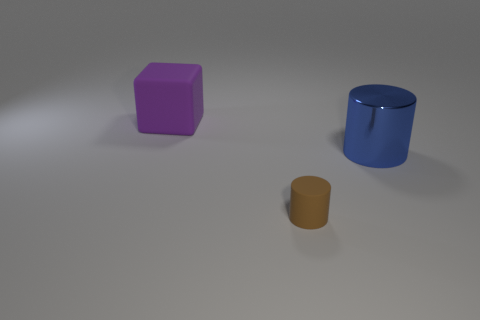There is a matte thing that is to the right of the big thing that is behind the big thing that is right of the purple object; what is its size?
Offer a very short reply. Small. Is the color of the large matte cube the same as the large metallic cylinder?
Offer a very short reply. No. Is there any other thing that is the same size as the cube?
Provide a succinct answer. Yes. How many brown matte cylinders are in front of the block?
Give a very brief answer. 1. Are there an equal number of tiny matte cylinders on the right side of the blue metal object and gray balls?
Your answer should be compact. Yes. What number of things are either cubes or tiny purple blocks?
Your response must be concise. 1. Is there anything else that has the same shape as the large purple thing?
Your answer should be very brief. No. What is the shape of the object behind the object right of the small rubber object?
Keep it short and to the point. Cube. The big purple thing that is made of the same material as the tiny brown object is what shape?
Ensure brevity in your answer.  Cube. There is a rubber thing that is behind the rubber thing that is in front of the big metal object; what size is it?
Offer a very short reply. Large. 